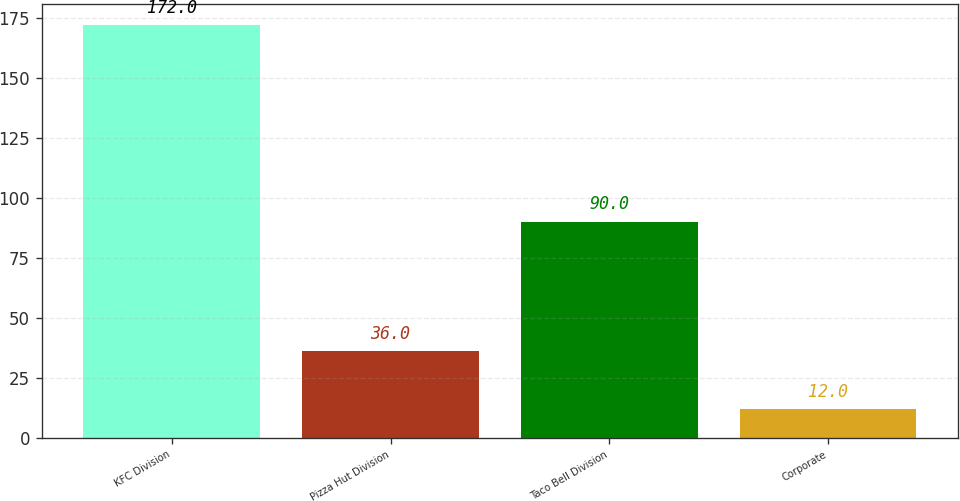Convert chart to OTSL. <chart><loc_0><loc_0><loc_500><loc_500><bar_chart><fcel>KFC Division<fcel>Pizza Hut Division<fcel>Taco Bell Division<fcel>Corporate<nl><fcel>172<fcel>36<fcel>90<fcel>12<nl></chart> 